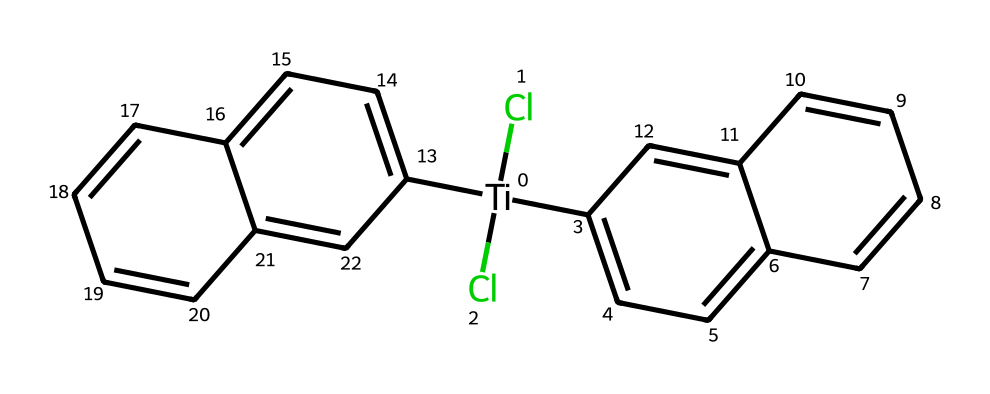What is the central metal atom in titanocene dichloride? By examining the SMILES representation, [Ti] indicates the presence of the titanium atom at the center of the compound.
Answer: titanium How many chlorine atoms are present in titanocene dichloride? The formula shows (Cl)(Cl), indicating the presence of two chlorine atoms attached to the titanium center.
Answer: two What type of bonding is primarily exhibited by the carbon rings in this compound? The presence of multiple carbon-carbon bonds within the aromatic rings shows that the bonding is characterized as delocalized pi bonding typical of aromatic compounds.
Answer: pi bonding What is the molecular formula represented in the SMILES structure? By analyzing the SMILES notation, the counts for each atom yield a molecular formula of C22H16Cl2Ti after accounting for all the atoms present.
Answer: C22H16Cl2Ti Which functional group is indicated by the presence of Cl in the structure? The presence of chlorine atoms signifies that this compound contains organochlorine functional groups, as chlorine is typically involved in such classifications.
Answer: organochlorine How many rings are present in titanocene dichloride's structure? The SMILES depicts two fused benzene rings, resulting in a total of two rings in the overall structure of titanocene dichloride.
Answer: two What is the primary purpose of studying titanocene dichloride in medical research? The exploration of this compound’s potential anti-cancer properties is the reason behind its synthesis and study in various scientific contexts.
Answer: anti-cancer 